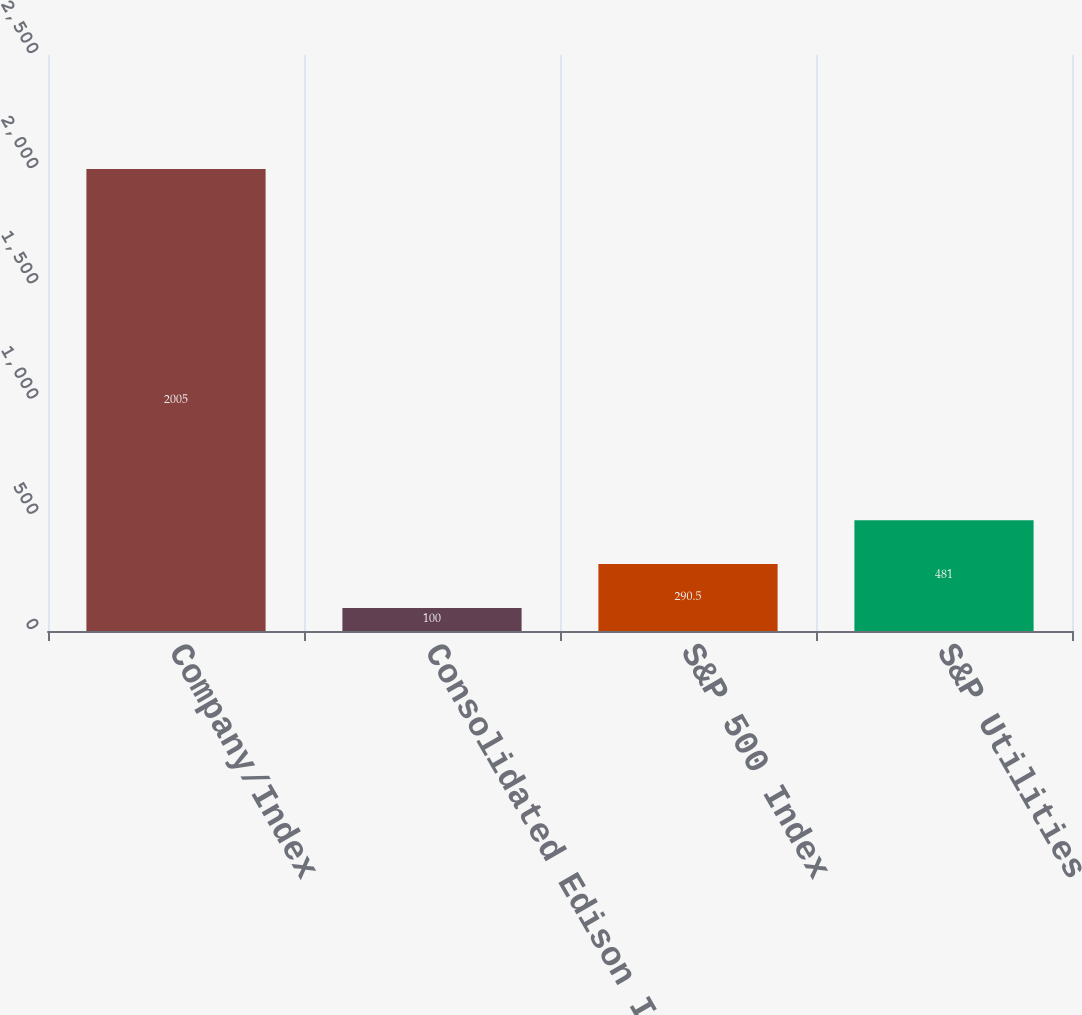<chart> <loc_0><loc_0><loc_500><loc_500><bar_chart><fcel>Company/Index<fcel>Consolidated Edison Inc<fcel>S&P 500 Index<fcel>S&P Utilities<nl><fcel>2005<fcel>100<fcel>290.5<fcel>481<nl></chart> 